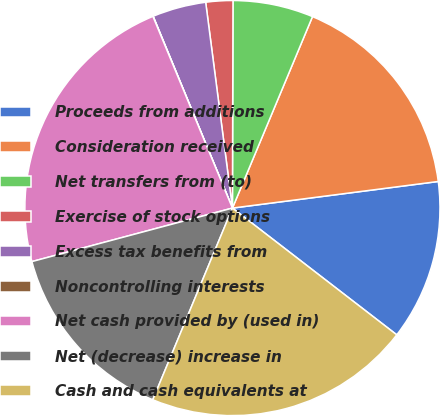Convert chart. <chart><loc_0><loc_0><loc_500><loc_500><pie_chart><fcel>Proceeds from additions<fcel>Consideration received<fcel>Net transfers from (to)<fcel>Exercise of stock options<fcel>Excess tax benefits from<fcel>Noncontrolling interests<fcel>Net cash provided by (used in)<fcel>Net (decrease) increase in<fcel>Cash and cash equivalents at<nl><fcel>12.5%<fcel>16.65%<fcel>6.26%<fcel>2.1%<fcel>4.18%<fcel>0.02%<fcel>22.89%<fcel>14.58%<fcel>20.81%<nl></chart> 